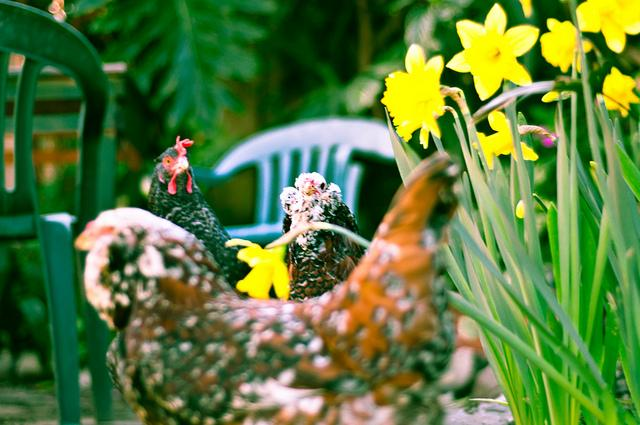What animal is near the flowers? Please explain your reasoning. rooster. The animal as evident is the roast one. 